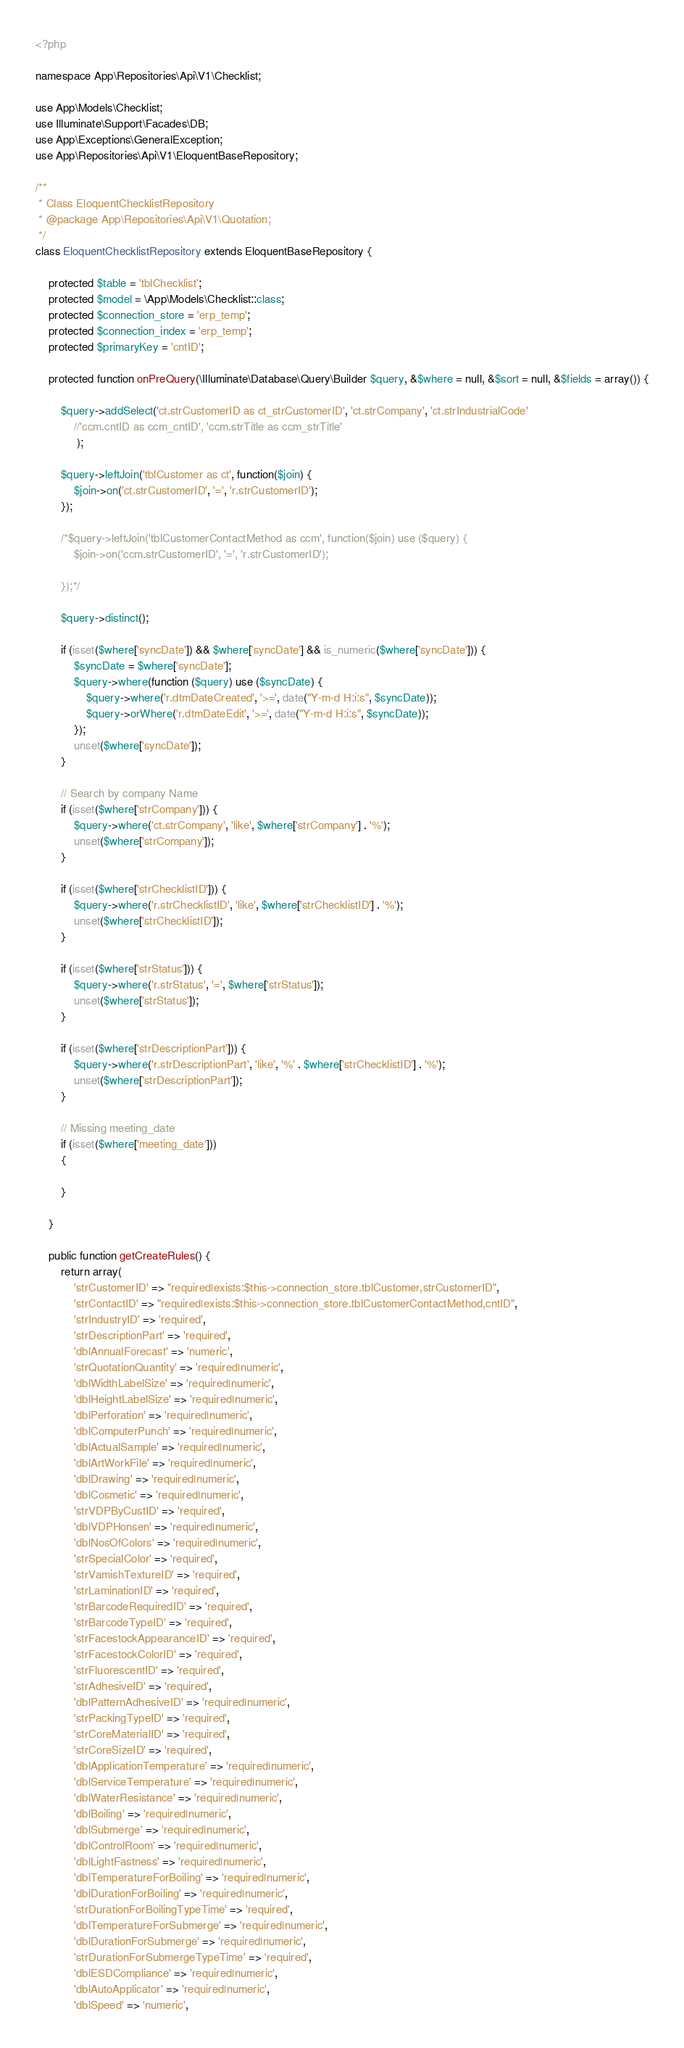Convert code to text. <code><loc_0><loc_0><loc_500><loc_500><_PHP_><?php

namespace App\Repositories\Api\V1\Checklist;

use App\Models\Checklist;
use Illuminate\Support\Facades\DB;
use App\Exceptions\GeneralException;
use App\Repositories\Api\V1\EloquentBaseRepository;

/**
 * Class EloquentChecklistRepository
 * @package App\Repositories\Api\V1\Quotation;
 */
class EloquentChecklistRepository extends EloquentBaseRepository {

    protected $table = 'tblChecklist';
    protected $model = \App\Models\Checklist::class;
    protected $connection_store = 'erp_temp';
    protected $connection_index = 'erp_temp';
    protected $primaryKey = 'cntID';

    protected function onPreQuery(\Illuminate\Database\Query\Builder $query, &$where = null, &$sort = null, &$fields = array()) {

        $query->addSelect('ct.strCustomerID as ct_strCustomerID', 'ct.strCompany', 'ct.strIndustrialCode' 
            //'ccm.cntID as ccm_cntID', 'ccm.strTitle as ccm_strTitle'
             ); 
        
        $query->leftJoin('tblCustomer as ct', function($join) {
            $join->on('ct.strCustomerID', '=', 'r.strCustomerID');
        });

        /*$query->leftJoin('tblCustomerContactMethod as ccm', function($join) use ($query) {
            $join->on('ccm.strCustomerID', '=', 'r.strCustomerID');
            
        });*/
        
        $query->distinct();
        
        if (isset($where['syncDate']) && $where['syncDate'] && is_numeric($where['syncDate'])) {
            $syncDate = $where['syncDate'];
            $query->where(function ($query) use ($syncDate) {
                $query->where('r.dtmDateCreated', '>=', date("Y-m-d H:i:s", $syncDate));
                $query->orWhere('r.dtmDateEdit', '>=', date("Y-m-d H:i:s", $syncDate));
            });
            unset($where['syncDate']);
        }
        
        // Search by company Name 
        if (isset($where['strCompany'])) {
            $query->where('ct.strCompany', 'like', $where['strCompany'] . '%');
            unset($where['strCompany']);
        }
        
        if (isset($where['strChecklistID'])) {
            $query->where('r.strChecklistID', 'like', $where['strChecklistID'] . '%');
            unset($where['strChecklistID']);
        }
        
        if (isset($where['strStatus'])) {
            $query->where('r.strStatus', '=', $where['strStatus']);
            unset($where['strStatus']);
        }
        
        if (isset($where['strDescriptionPart'])) {
            $query->where('r.strDescriptionPart', 'like', '%' . $where['strChecklistID'] . '%');
            unset($where['strDescriptionPart']);
        }
        
        // Missing meeting_date
        if (isset($where['meeting_date'])) 
        {

        }

    }

    public function getCreateRules() {
        return array(
            'strCustomerID' => "required|exists:$this->connection_store.tblCustomer,strCustomerID",
            'strContactID' => "required|exists:$this->connection_store.tblCustomerContactMethod,cntID",
            'strIndustryID' => 'required',
            'strDescriptionPart' => 'required',
            'dblAnnualForecast' => 'numeric',
            'strQuotationQuantity' => 'required|numeric',
            'dblWidthLabelSize' => 'required|numeric',
            'dblHeightLabelSize' => 'required|numeric',
            'dblPerforation' => 'required|numeric',
            'dblComputerPunch' => 'required|numeric',
            'dblActualSample' => 'required|numeric',
            'dblArtWorkFile' => 'required|numeric',
            'dblDrawing' => 'required|numeric',
            'dblCosmetic' => 'required|numeric',
            'strVDPByCustID' => 'required',
            'dblVDPHonsen' => 'required|numeric',
            'dblNosOfColors' => 'required|numeric',
            'strSpecialColor' => 'required',
            'strVamishTextureID' => 'required',
            'strLaminationID' => 'required',
            'strBarcodeRequiredID' => 'required',
            'strBarcodeTypeID' => 'required',
            'strFacestockAppearanceID' => 'required',
            'strFacestockColorID' => 'required',
            'strFluorescentID' => 'required',
            'strAdhesiveID' => 'required',
            'dblPatternAdhesiveID' => 'required|numeric',
            'strPackingTypeID' => 'required',
            'strCoreMaterialID' => 'required',
            'strCoreSizeID' => 'required',
            'dblApplicationTemperature' => 'required|numeric',
            'dblServiceTemperature' => 'required|numeric',
            'dblWaterResistance' => 'required|numeric',
            'dblBoiling' => 'required|numeric',
            'dblSubmerge' => 'required|numeric',
            'dblControlRoom' => 'required|numeric',
            'dblLightFastness' => 'required|numeric',
            'dblTemperatureForBoiling' => 'required|numeric',
            'dblDurationForBoiling' => 'required|numeric',
            'strDurationForBoilingTypeTime' => 'required',
            'dblTemperatureForSubmerge' => 'required|numeric',
            'dblDurationForSubmerge' => 'required|numeric',
            'strDurationForSubmergeTypeTime' => 'required',
            'dblESDCompliance' => 'required|numeric',
            'dblAutoApplicator' => 'required|numeric',
            'dblSpeed' => 'numeric',</code> 